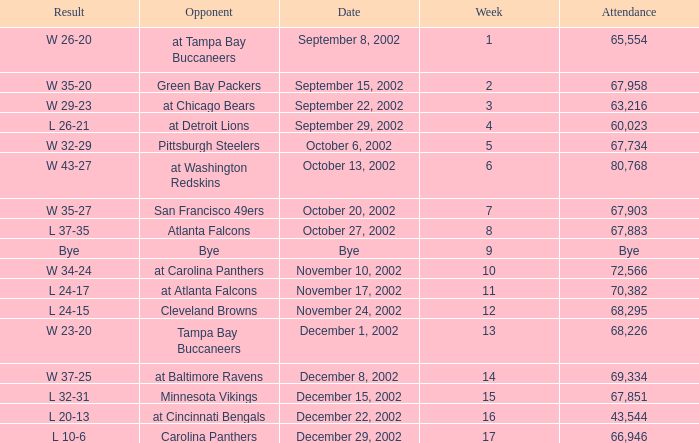Who was the opposing team in the game attended by 65,554? At tampa bay buccaneers. 